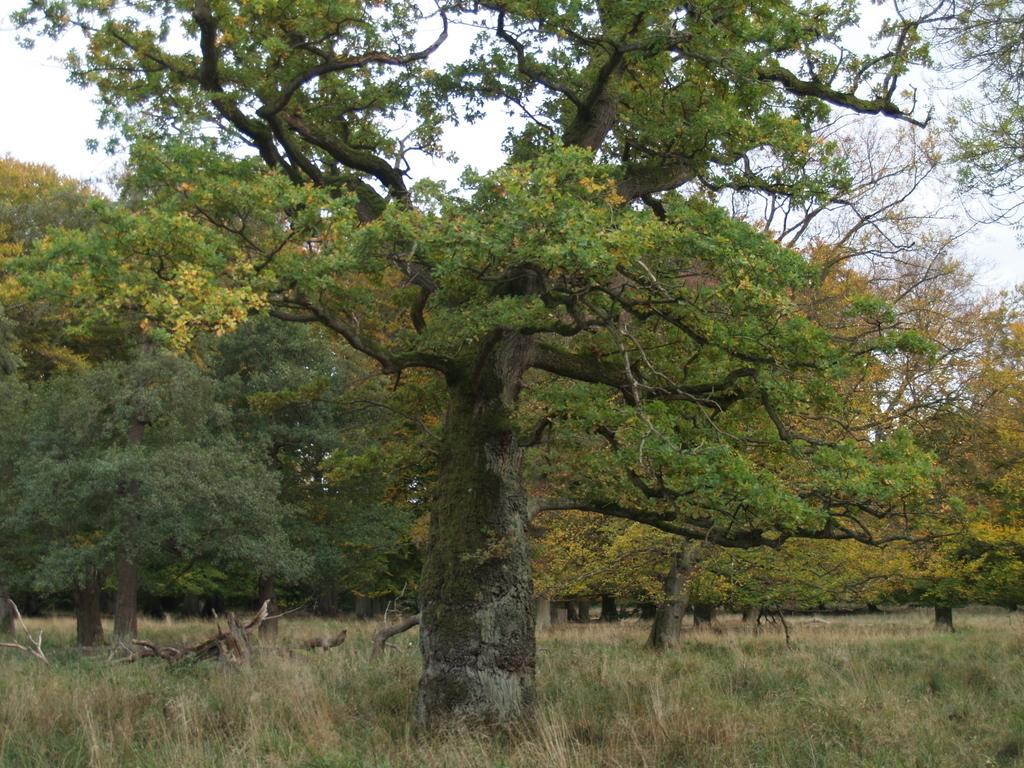What can be seen in the background of the image? The sky is visible in the background of the image. What type of vegetation is present in the image? There are trees and grass plants in the image. Can you describe any specific features of the trees? Yes, there are branches visible in the image. What type of mine is depicted in the image? There is no mine present in the image; it features trees, branches, grass plants, and a visible sky. What scientific discoveries can be observed in the image? The image does not depict any scientific discoveries; it is a natural scene with trees, branches, grass plants, and a visible sky. 